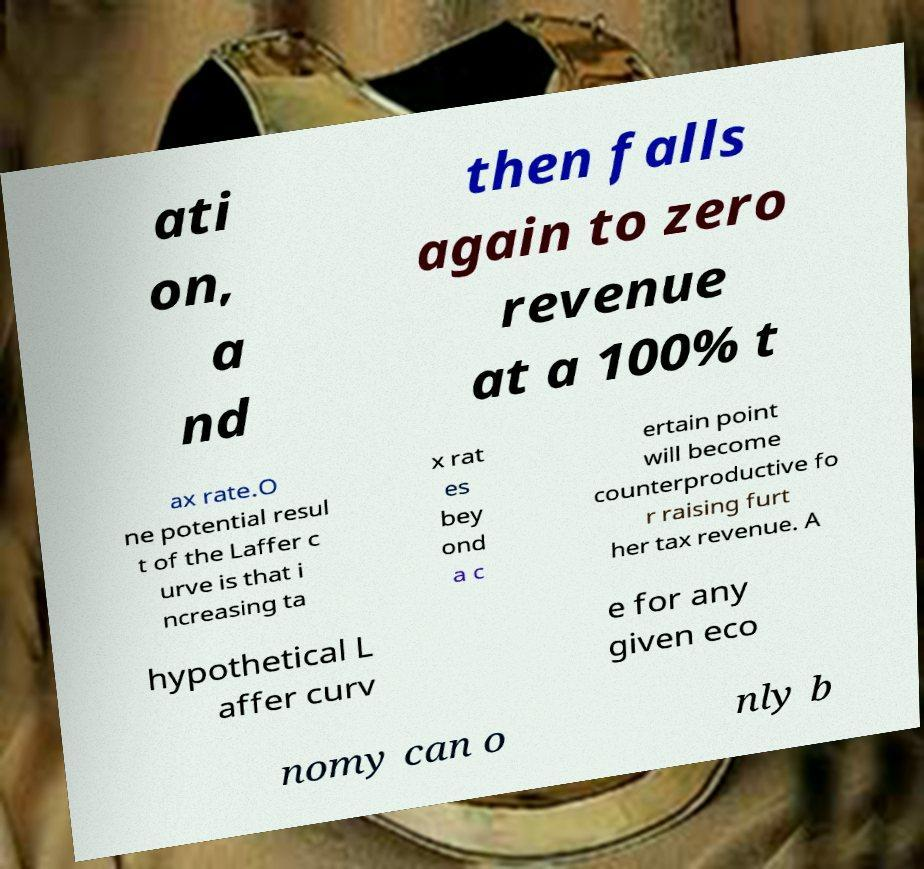I need the written content from this picture converted into text. Can you do that? ati on, a nd then falls again to zero revenue at a 100% t ax rate.O ne potential resul t of the Laffer c urve is that i ncreasing ta x rat es bey ond a c ertain point will become counterproductive fo r raising furt her tax revenue. A hypothetical L affer curv e for any given eco nomy can o nly b 